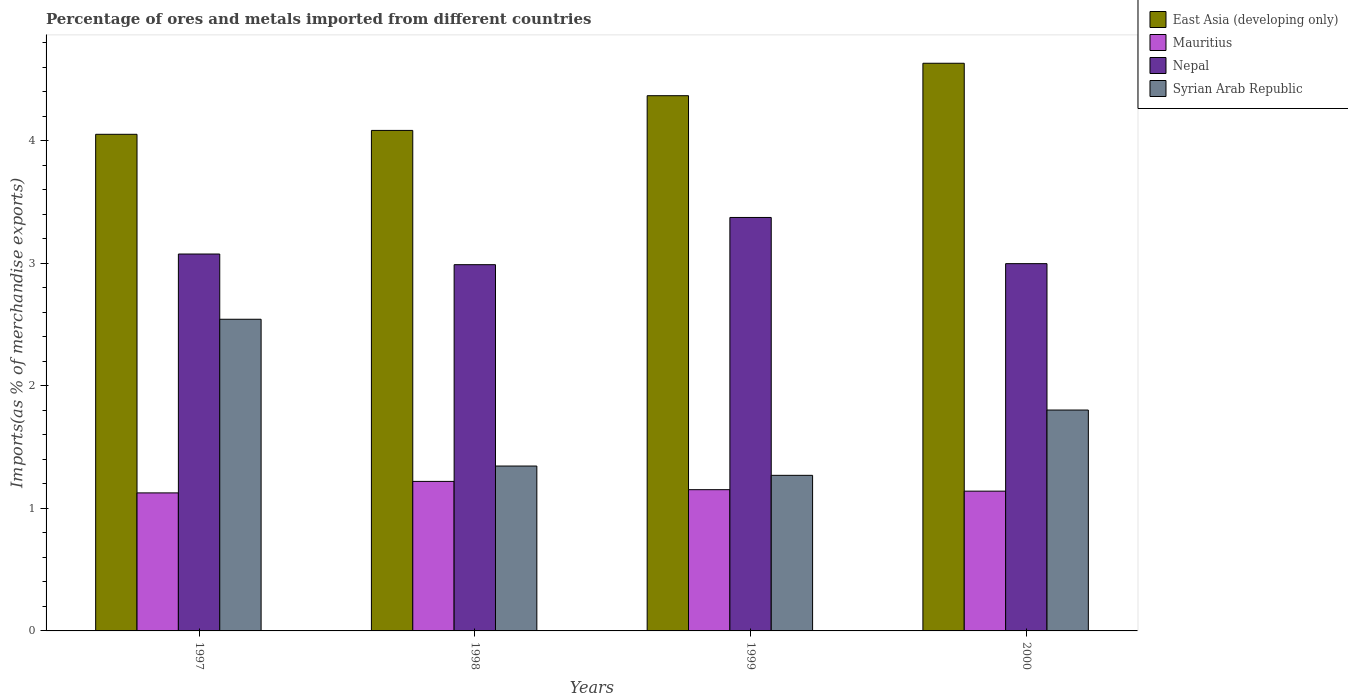Are the number of bars per tick equal to the number of legend labels?
Keep it short and to the point. Yes. Are the number of bars on each tick of the X-axis equal?
Your response must be concise. Yes. How many bars are there on the 2nd tick from the right?
Ensure brevity in your answer.  4. What is the label of the 2nd group of bars from the left?
Provide a short and direct response. 1998. In how many cases, is the number of bars for a given year not equal to the number of legend labels?
Keep it short and to the point. 0. What is the percentage of imports to different countries in East Asia (developing only) in 1997?
Provide a succinct answer. 4.05. Across all years, what is the maximum percentage of imports to different countries in Nepal?
Make the answer very short. 3.37. Across all years, what is the minimum percentage of imports to different countries in East Asia (developing only)?
Offer a terse response. 4.05. What is the total percentage of imports to different countries in Syrian Arab Republic in the graph?
Provide a succinct answer. 6.96. What is the difference between the percentage of imports to different countries in East Asia (developing only) in 1999 and that in 2000?
Offer a very short reply. -0.26. What is the difference between the percentage of imports to different countries in Syrian Arab Republic in 2000 and the percentage of imports to different countries in Nepal in 1998?
Offer a terse response. -1.19. What is the average percentage of imports to different countries in Mauritius per year?
Provide a succinct answer. 1.16. In the year 1997, what is the difference between the percentage of imports to different countries in Nepal and percentage of imports to different countries in East Asia (developing only)?
Keep it short and to the point. -0.98. What is the ratio of the percentage of imports to different countries in Nepal in 1997 to that in 1999?
Provide a short and direct response. 0.91. Is the difference between the percentage of imports to different countries in Nepal in 1997 and 1999 greater than the difference between the percentage of imports to different countries in East Asia (developing only) in 1997 and 1999?
Provide a short and direct response. Yes. What is the difference between the highest and the second highest percentage of imports to different countries in Syrian Arab Republic?
Give a very brief answer. 0.74. What is the difference between the highest and the lowest percentage of imports to different countries in Syrian Arab Republic?
Provide a short and direct response. 1.27. In how many years, is the percentage of imports to different countries in Nepal greater than the average percentage of imports to different countries in Nepal taken over all years?
Offer a terse response. 1. Is the sum of the percentage of imports to different countries in East Asia (developing only) in 1997 and 1998 greater than the maximum percentage of imports to different countries in Syrian Arab Republic across all years?
Provide a short and direct response. Yes. Is it the case that in every year, the sum of the percentage of imports to different countries in Mauritius and percentage of imports to different countries in East Asia (developing only) is greater than the sum of percentage of imports to different countries in Syrian Arab Republic and percentage of imports to different countries in Nepal?
Ensure brevity in your answer.  No. What does the 1st bar from the left in 2000 represents?
Provide a succinct answer. East Asia (developing only). What does the 2nd bar from the right in 1997 represents?
Provide a short and direct response. Nepal. How many bars are there?
Your response must be concise. 16. Are all the bars in the graph horizontal?
Ensure brevity in your answer.  No. How many years are there in the graph?
Offer a terse response. 4. What is the difference between two consecutive major ticks on the Y-axis?
Ensure brevity in your answer.  1. Does the graph contain grids?
Make the answer very short. No. How many legend labels are there?
Your response must be concise. 4. What is the title of the graph?
Make the answer very short. Percentage of ores and metals imported from different countries. Does "Moldova" appear as one of the legend labels in the graph?
Offer a very short reply. No. What is the label or title of the X-axis?
Make the answer very short. Years. What is the label or title of the Y-axis?
Keep it short and to the point. Imports(as % of merchandise exports). What is the Imports(as % of merchandise exports) of East Asia (developing only) in 1997?
Make the answer very short. 4.05. What is the Imports(as % of merchandise exports) in Mauritius in 1997?
Your answer should be very brief. 1.13. What is the Imports(as % of merchandise exports) in Nepal in 1997?
Make the answer very short. 3.07. What is the Imports(as % of merchandise exports) in Syrian Arab Republic in 1997?
Your answer should be compact. 2.54. What is the Imports(as % of merchandise exports) of East Asia (developing only) in 1998?
Keep it short and to the point. 4.08. What is the Imports(as % of merchandise exports) in Mauritius in 1998?
Make the answer very short. 1.22. What is the Imports(as % of merchandise exports) of Nepal in 1998?
Offer a very short reply. 2.99. What is the Imports(as % of merchandise exports) in Syrian Arab Republic in 1998?
Provide a succinct answer. 1.35. What is the Imports(as % of merchandise exports) of East Asia (developing only) in 1999?
Make the answer very short. 4.37. What is the Imports(as % of merchandise exports) of Mauritius in 1999?
Make the answer very short. 1.15. What is the Imports(as % of merchandise exports) of Nepal in 1999?
Offer a very short reply. 3.37. What is the Imports(as % of merchandise exports) in Syrian Arab Republic in 1999?
Provide a short and direct response. 1.27. What is the Imports(as % of merchandise exports) of East Asia (developing only) in 2000?
Keep it short and to the point. 4.63. What is the Imports(as % of merchandise exports) in Mauritius in 2000?
Offer a very short reply. 1.14. What is the Imports(as % of merchandise exports) in Nepal in 2000?
Make the answer very short. 3. What is the Imports(as % of merchandise exports) of Syrian Arab Republic in 2000?
Keep it short and to the point. 1.8. Across all years, what is the maximum Imports(as % of merchandise exports) in East Asia (developing only)?
Make the answer very short. 4.63. Across all years, what is the maximum Imports(as % of merchandise exports) in Mauritius?
Your answer should be very brief. 1.22. Across all years, what is the maximum Imports(as % of merchandise exports) in Nepal?
Ensure brevity in your answer.  3.37. Across all years, what is the maximum Imports(as % of merchandise exports) of Syrian Arab Republic?
Your answer should be very brief. 2.54. Across all years, what is the minimum Imports(as % of merchandise exports) in East Asia (developing only)?
Ensure brevity in your answer.  4.05. Across all years, what is the minimum Imports(as % of merchandise exports) of Mauritius?
Your answer should be very brief. 1.13. Across all years, what is the minimum Imports(as % of merchandise exports) in Nepal?
Give a very brief answer. 2.99. Across all years, what is the minimum Imports(as % of merchandise exports) of Syrian Arab Republic?
Your answer should be compact. 1.27. What is the total Imports(as % of merchandise exports) of East Asia (developing only) in the graph?
Ensure brevity in your answer.  17.13. What is the total Imports(as % of merchandise exports) in Mauritius in the graph?
Your answer should be compact. 4.64. What is the total Imports(as % of merchandise exports) of Nepal in the graph?
Provide a short and direct response. 12.43. What is the total Imports(as % of merchandise exports) of Syrian Arab Republic in the graph?
Make the answer very short. 6.96. What is the difference between the Imports(as % of merchandise exports) in East Asia (developing only) in 1997 and that in 1998?
Provide a succinct answer. -0.03. What is the difference between the Imports(as % of merchandise exports) of Mauritius in 1997 and that in 1998?
Your answer should be compact. -0.09. What is the difference between the Imports(as % of merchandise exports) in Nepal in 1997 and that in 1998?
Offer a very short reply. 0.09. What is the difference between the Imports(as % of merchandise exports) of Syrian Arab Republic in 1997 and that in 1998?
Offer a terse response. 1.2. What is the difference between the Imports(as % of merchandise exports) of East Asia (developing only) in 1997 and that in 1999?
Give a very brief answer. -0.32. What is the difference between the Imports(as % of merchandise exports) in Mauritius in 1997 and that in 1999?
Your answer should be compact. -0.03. What is the difference between the Imports(as % of merchandise exports) of Nepal in 1997 and that in 1999?
Ensure brevity in your answer.  -0.3. What is the difference between the Imports(as % of merchandise exports) in Syrian Arab Republic in 1997 and that in 1999?
Your response must be concise. 1.27. What is the difference between the Imports(as % of merchandise exports) in East Asia (developing only) in 1997 and that in 2000?
Ensure brevity in your answer.  -0.58. What is the difference between the Imports(as % of merchandise exports) in Mauritius in 1997 and that in 2000?
Offer a very short reply. -0.01. What is the difference between the Imports(as % of merchandise exports) in Nepal in 1997 and that in 2000?
Your answer should be very brief. 0.08. What is the difference between the Imports(as % of merchandise exports) of Syrian Arab Republic in 1997 and that in 2000?
Your answer should be very brief. 0.74. What is the difference between the Imports(as % of merchandise exports) of East Asia (developing only) in 1998 and that in 1999?
Provide a short and direct response. -0.28. What is the difference between the Imports(as % of merchandise exports) of Mauritius in 1998 and that in 1999?
Provide a succinct answer. 0.07. What is the difference between the Imports(as % of merchandise exports) in Nepal in 1998 and that in 1999?
Provide a short and direct response. -0.39. What is the difference between the Imports(as % of merchandise exports) in Syrian Arab Republic in 1998 and that in 1999?
Keep it short and to the point. 0.08. What is the difference between the Imports(as % of merchandise exports) in East Asia (developing only) in 1998 and that in 2000?
Your response must be concise. -0.55. What is the difference between the Imports(as % of merchandise exports) of Mauritius in 1998 and that in 2000?
Give a very brief answer. 0.08. What is the difference between the Imports(as % of merchandise exports) of Nepal in 1998 and that in 2000?
Your response must be concise. -0.01. What is the difference between the Imports(as % of merchandise exports) of Syrian Arab Republic in 1998 and that in 2000?
Ensure brevity in your answer.  -0.46. What is the difference between the Imports(as % of merchandise exports) of East Asia (developing only) in 1999 and that in 2000?
Offer a very short reply. -0.26. What is the difference between the Imports(as % of merchandise exports) in Mauritius in 1999 and that in 2000?
Offer a terse response. 0.01. What is the difference between the Imports(as % of merchandise exports) in Nepal in 1999 and that in 2000?
Give a very brief answer. 0.38. What is the difference between the Imports(as % of merchandise exports) of Syrian Arab Republic in 1999 and that in 2000?
Your answer should be compact. -0.53. What is the difference between the Imports(as % of merchandise exports) of East Asia (developing only) in 1997 and the Imports(as % of merchandise exports) of Mauritius in 1998?
Keep it short and to the point. 2.83. What is the difference between the Imports(as % of merchandise exports) of East Asia (developing only) in 1997 and the Imports(as % of merchandise exports) of Nepal in 1998?
Provide a succinct answer. 1.06. What is the difference between the Imports(as % of merchandise exports) in East Asia (developing only) in 1997 and the Imports(as % of merchandise exports) in Syrian Arab Republic in 1998?
Give a very brief answer. 2.71. What is the difference between the Imports(as % of merchandise exports) of Mauritius in 1997 and the Imports(as % of merchandise exports) of Nepal in 1998?
Ensure brevity in your answer.  -1.86. What is the difference between the Imports(as % of merchandise exports) in Mauritius in 1997 and the Imports(as % of merchandise exports) in Syrian Arab Republic in 1998?
Keep it short and to the point. -0.22. What is the difference between the Imports(as % of merchandise exports) in Nepal in 1997 and the Imports(as % of merchandise exports) in Syrian Arab Republic in 1998?
Provide a succinct answer. 1.73. What is the difference between the Imports(as % of merchandise exports) of East Asia (developing only) in 1997 and the Imports(as % of merchandise exports) of Mauritius in 1999?
Ensure brevity in your answer.  2.9. What is the difference between the Imports(as % of merchandise exports) in East Asia (developing only) in 1997 and the Imports(as % of merchandise exports) in Nepal in 1999?
Make the answer very short. 0.68. What is the difference between the Imports(as % of merchandise exports) in East Asia (developing only) in 1997 and the Imports(as % of merchandise exports) in Syrian Arab Republic in 1999?
Your answer should be compact. 2.78. What is the difference between the Imports(as % of merchandise exports) of Mauritius in 1997 and the Imports(as % of merchandise exports) of Nepal in 1999?
Offer a very short reply. -2.25. What is the difference between the Imports(as % of merchandise exports) in Mauritius in 1997 and the Imports(as % of merchandise exports) in Syrian Arab Republic in 1999?
Offer a terse response. -0.14. What is the difference between the Imports(as % of merchandise exports) in Nepal in 1997 and the Imports(as % of merchandise exports) in Syrian Arab Republic in 1999?
Provide a succinct answer. 1.81. What is the difference between the Imports(as % of merchandise exports) in East Asia (developing only) in 1997 and the Imports(as % of merchandise exports) in Mauritius in 2000?
Provide a short and direct response. 2.91. What is the difference between the Imports(as % of merchandise exports) in East Asia (developing only) in 1997 and the Imports(as % of merchandise exports) in Nepal in 2000?
Offer a very short reply. 1.06. What is the difference between the Imports(as % of merchandise exports) in East Asia (developing only) in 1997 and the Imports(as % of merchandise exports) in Syrian Arab Republic in 2000?
Provide a short and direct response. 2.25. What is the difference between the Imports(as % of merchandise exports) of Mauritius in 1997 and the Imports(as % of merchandise exports) of Nepal in 2000?
Offer a terse response. -1.87. What is the difference between the Imports(as % of merchandise exports) of Mauritius in 1997 and the Imports(as % of merchandise exports) of Syrian Arab Republic in 2000?
Your answer should be compact. -0.68. What is the difference between the Imports(as % of merchandise exports) in Nepal in 1997 and the Imports(as % of merchandise exports) in Syrian Arab Republic in 2000?
Ensure brevity in your answer.  1.27. What is the difference between the Imports(as % of merchandise exports) in East Asia (developing only) in 1998 and the Imports(as % of merchandise exports) in Mauritius in 1999?
Your answer should be compact. 2.93. What is the difference between the Imports(as % of merchandise exports) of East Asia (developing only) in 1998 and the Imports(as % of merchandise exports) of Nepal in 1999?
Make the answer very short. 0.71. What is the difference between the Imports(as % of merchandise exports) of East Asia (developing only) in 1998 and the Imports(as % of merchandise exports) of Syrian Arab Republic in 1999?
Your answer should be compact. 2.81. What is the difference between the Imports(as % of merchandise exports) in Mauritius in 1998 and the Imports(as % of merchandise exports) in Nepal in 1999?
Your answer should be very brief. -2.15. What is the difference between the Imports(as % of merchandise exports) of Mauritius in 1998 and the Imports(as % of merchandise exports) of Syrian Arab Republic in 1999?
Give a very brief answer. -0.05. What is the difference between the Imports(as % of merchandise exports) of Nepal in 1998 and the Imports(as % of merchandise exports) of Syrian Arab Republic in 1999?
Provide a short and direct response. 1.72. What is the difference between the Imports(as % of merchandise exports) in East Asia (developing only) in 1998 and the Imports(as % of merchandise exports) in Mauritius in 2000?
Give a very brief answer. 2.94. What is the difference between the Imports(as % of merchandise exports) of East Asia (developing only) in 1998 and the Imports(as % of merchandise exports) of Nepal in 2000?
Provide a short and direct response. 1.09. What is the difference between the Imports(as % of merchandise exports) of East Asia (developing only) in 1998 and the Imports(as % of merchandise exports) of Syrian Arab Republic in 2000?
Offer a terse response. 2.28. What is the difference between the Imports(as % of merchandise exports) of Mauritius in 1998 and the Imports(as % of merchandise exports) of Nepal in 2000?
Give a very brief answer. -1.78. What is the difference between the Imports(as % of merchandise exports) in Mauritius in 1998 and the Imports(as % of merchandise exports) in Syrian Arab Republic in 2000?
Provide a short and direct response. -0.58. What is the difference between the Imports(as % of merchandise exports) of Nepal in 1998 and the Imports(as % of merchandise exports) of Syrian Arab Republic in 2000?
Give a very brief answer. 1.19. What is the difference between the Imports(as % of merchandise exports) of East Asia (developing only) in 1999 and the Imports(as % of merchandise exports) of Mauritius in 2000?
Make the answer very short. 3.23. What is the difference between the Imports(as % of merchandise exports) in East Asia (developing only) in 1999 and the Imports(as % of merchandise exports) in Nepal in 2000?
Offer a very short reply. 1.37. What is the difference between the Imports(as % of merchandise exports) in East Asia (developing only) in 1999 and the Imports(as % of merchandise exports) in Syrian Arab Republic in 2000?
Provide a succinct answer. 2.56. What is the difference between the Imports(as % of merchandise exports) of Mauritius in 1999 and the Imports(as % of merchandise exports) of Nepal in 2000?
Your response must be concise. -1.84. What is the difference between the Imports(as % of merchandise exports) in Mauritius in 1999 and the Imports(as % of merchandise exports) in Syrian Arab Republic in 2000?
Ensure brevity in your answer.  -0.65. What is the difference between the Imports(as % of merchandise exports) of Nepal in 1999 and the Imports(as % of merchandise exports) of Syrian Arab Republic in 2000?
Keep it short and to the point. 1.57. What is the average Imports(as % of merchandise exports) in East Asia (developing only) per year?
Provide a succinct answer. 4.28. What is the average Imports(as % of merchandise exports) of Mauritius per year?
Keep it short and to the point. 1.16. What is the average Imports(as % of merchandise exports) of Nepal per year?
Provide a succinct answer. 3.11. What is the average Imports(as % of merchandise exports) in Syrian Arab Republic per year?
Your response must be concise. 1.74. In the year 1997, what is the difference between the Imports(as % of merchandise exports) of East Asia (developing only) and Imports(as % of merchandise exports) of Mauritius?
Provide a succinct answer. 2.93. In the year 1997, what is the difference between the Imports(as % of merchandise exports) of East Asia (developing only) and Imports(as % of merchandise exports) of Nepal?
Ensure brevity in your answer.  0.98. In the year 1997, what is the difference between the Imports(as % of merchandise exports) of East Asia (developing only) and Imports(as % of merchandise exports) of Syrian Arab Republic?
Offer a terse response. 1.51. In the year 1997, what is the difference between the Imports(as % of merchandise exports) of Mauritius and Imports(as % of merchandise exports) of Nepal?
Give a very brief answer. -1.95. In the year 1997, what is the difference between the Imports(as % of merchandise exports) in Mauritius and Imports(as % of merchandise exports) in Syrian Arab Republic?
Provide a short and direct response. -1.42. In the year 1997, what is the difference between the Imports(as % of merchandise exports) of Nepal and Imports(as % of merchandise exports) of Syrian Arab Republic?
Your response must be concise. 0.53. In the year 1998, what is the difference between the Imports(as % of merchandise exports) in East Asia (developing only) and Imports(as % of merchandise exports) in Mauritius?
Offer a terse response. 2.86. In the year 1998, what is the difference between the Imports(as % of merchandise exports) of East Asia (developing only) and Imports(as % of merchandise exports) of Nepal?
Ensure brevity in your answer.  1.1. In the year 1998, what is the difference between the Imports(as % of merchandise exports) in East Asia (developing only) and Imports(as % of merchandise exports) in Syrian Arab Republic?
Your response must be concise. 2.74. In the year 1998, what is the difference between the Imports(as % of merchandise exports) of Mauritius and Imports(as % of merchandise exports) of Nepal?
Your answer should be very brief. -1.77. In the year 1998, what is the difference between the Imports(as % of merchandise exports) of Mauritius and Imports(as % of merchandise exports) of Syrian Arab Republic?
Ensure brevity in your answer.  -0.13. In the year 1998, what is the difference between the Imports(as % of merchandise exports) in Nepal and Imports(as % of merchandise exports) in Syrian Arab Republic?
Make the answer very short. 1.64. In the year 1999, what is the difference between the Imports(as % of merchandise exports) of East Asia (developing only) and Imports(as % of merchandise exports) of Mauritius?
Keep it short and to the point. 3.21. In the year 1999, what is the difference between the Imports(as % of merchandise exports) of East Asia (developing only) and Imports(as % of merchandise exports) of Syrian Arab Republic?
Your response must be concise. 3.1. In the year 1999, what is the difference between the Imports(as % of merchandise exports) of Mauritius and Imports(as % of merchandise exports) of Nepal?
Your response must be concise. -2.22. In the year 1999, what is the difference between the Imports(as % of merchandise exports) in Mauritius and Imports(as % of merchandise exports) in Syrian Arab Republic?
Provide a succinct answer. -0.12. In the year 1999, what is the difference between the Imports(as % of merchandise exports) in Nepal and Imports(as % of merchandise exports) in Syrian Arab Republic?
Keep it short and to the point. 2.1. In the year 2000, what is the difference between the Imports(as % of merchandise exports) of East Asia (developing only) and Imports(as % of merchandise exports) of Mauritius?
Make the answer very short. 3.49. In the year 2000, what is the difference between the Imports(as % of merchandise exports) of East Asia (developing only) and Imports(as % of merchandise exports) of Nepal?
Offer a terse response. 1.63. In the year 2000, what is the difference between the Imports(as % of merchandise exports) of East Asia (developing only) and Imports(as % of merchandise exports) of Syrian Arab Republic?
Your response must be concise. 2.83. In the year 2000, what is the difference between the Imports(as % of merchandise exports) of Mauritius and Imports(as % of merchandise exports) of Nepal?
Keep it short and to the point. -1.86. In the year 2000, what is the difference between the Imports(as % of merchandise exports) in Mauritius and Imports(as % of merchandise exports) in Syrian Arab Republic?
Your answer should be very brief. -0.66. In the year 2000, what is the difference between the Imports(as % of merchandise exports) in Nepal and Imports(as % of merchandise exports) in Syrian Arab Republic?
Make the answer very short. 1.19. What is the ratio of the Imports(as % of merchandise exports) in Mauritius in 1997 to that in 1998?
Keep it short and to the point. 0.92. What is the ratio of the Imports(as % of merchandise exports) in Nepal in 1997 to that in 1998?
Keep it short and to the point. 1.03. What is the ratio of the Imports(as % of merchandise exports) of Syrian Arab Republic in 1997 to that in 1998?
Your answer should be compact. 1.89. What is the ratio of the Imports(as % of merchandise exports) in East Asia (developing only) in 1997 to that in 1999?
Keep it short and to the point. 0.93. What is the ratio of the Imports(as % of merchandise exports) of Mauritius in 1997 to that in 1999?
Make the answer very short. 0.98. What is the ratio of the Imports(as % of merchandise exports) of Nepal in 1997 to that in 1999?
Keep it short and to the point. 0.91. What is the ratio of the Imports(as % of merchandise exports) of Syrian Arab Republic in 1997 to that in 1999?
Offer a very short reply. 2. What is the ratio of the Imports(as % of merchandise exports) of East Asia (developing only) in 1997 to that in 2000?
Make the answer very short. 0.87. What is the ratio of the Imports(as % of merchandise exports) in Mauritius in 1997 to that in 2000?
Ensure brevity in your answer.  0.99. What is the ratio of the Imports(as % of merchandise exports) of Nepal in 1997 to that in 2000?
Offer a terse response. 1.03. What is the ratio of the Imports(as % of merchandise exports) in Syrian Arab Republic in 1997 to that in 2000?
Give a very brief answer. 1.41. What is the ratio of the Imports(as % of merchandise exports) in East Asia (developing only) in 1998 to that in 1999?
Offer a terse response. 0.94. What is the ratio of the Imports(as % of merchandise exports) in Mauritius in 1998 to that in 1999?
Your answer should be very brief. 1.06. What is the ratio of the Imports(as % of merchandise exports) in Nepal in 1998 to that in 1999?
Give a very brief answer. 0.89. What is the ratio of the Imports(as % of merchandise exports) in Syrian Arab Republic in 1998 to that in 1999?
Ensure brevity in your answer.  1.06. What is the ratio of the Imports(as % of merchandise exports) in East Asia (developing only) in 1998 to that in 2000?
Provide a succinct answer. 0.88. What is the ratio of the Imports(as % of merchandise exports) in Mauritius in 1998 to that in 2000?
Your answer should be compact. 1.07. What is the ratio of the Imports(as % of merchandise exports) of Nepal in 1998 to that in 2000?
Keep it short and to the point. 1. What is the ratio of the Imports(as % of merchandise exports) of Syrian Arab Republic in 1998 to that in 2000?
Make the answer very short. 0.75. What is the ratio of the Imports(as % of merchandise exports) in East Asia (developing only) in 1999 to that in 2000?
Ensure brevity in your answer.  0.94. What is the ratio of the Imports(as % of merchandise exports) in Mauritius in 1999 to that in 2000?
Your answer should be very brief. 1.01. What is the ratio of the Imports(as % of merchandise exports) in Nepal in 1999 to that in 2000?
Your response must be concise. 1.13. What is the ratio of the Imports(as % of merchandise exports) of Syrian Arab Republic in 1999 to that in 2000?
Your answer should be compact. 0.7. What is the difference between the highest and the second highest Imports(as % of merchandise exports) in East Asia (developing only)?
Offer a very short reply. 0.26. What is the difference between the highest and the second highest Imports(as % of merchandise exports) in Mauritius?
Provide a succinct answer. 0.07. What is the difference between the highest and the second highest Imports(as % of merchandise exports) of Nepal?
Your response must be concise. 0.3. What is the difference between the highest and the second highest Imports(as % of merchandise exports) in Syrian Arab Republic?
Offer a terse response. 0.74. What is the difference between the highest and the lowest Imports(as % of merchandise exports) in East Asia (developing only)?
Your answer should be very brief. 0.58. What is the difference between the highest and the lowest Imports(as % of merchandise exports) of Mauritius?
Your response must be concise. 0.09. What is the difference between the highest and the lowest Imports(as % of merchandise exports) of Nepal?
Keep it short and to the point. 0.39. What is the difference between the highest and the lowest Imports(as % of merchandise exports) of Syrian Arab Republic?
Offer a terse response. 1.27. 